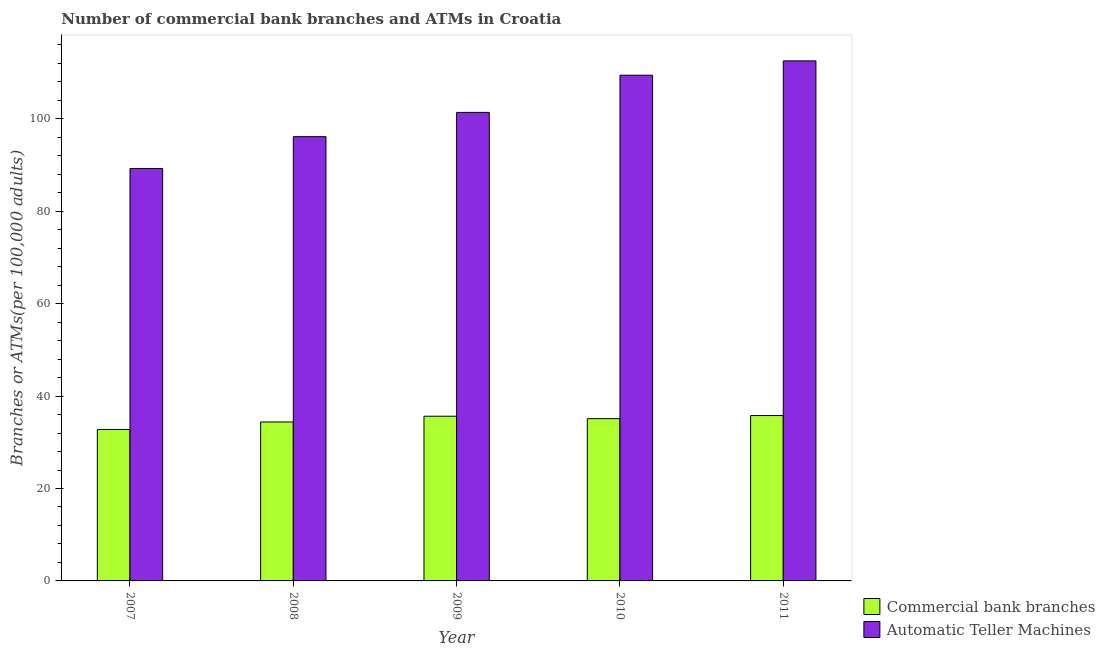How many groups of bars are there?
Provide a succinct answer. 5. Are the number of bars on each tick of the X-axis equal?
Make the answer very short. Yes. How many bars are there on the 5th tick from the right?
Keep it short and to the point. 2. What is the label of the 5th group of bars from the left?
Make the answer very short. 2011. In how many cases, is the number of bars for a given year not equal to the number of legend labels?
Ensure brevity in your answer.  0. What is the number of commercal bank branches in 2008?
Your answer should be very brief. 34.4. Across all years, what is the maximum number of atms?
Ensure brevity in your answer.  112.54. Across all years, what is the minimum number of atms?
Give a very brief answer. 89.25. In which year was the number of atms maximum?
Provide a short and direct response. 2011. In which year was the number of atms minimum?
Offer a terse response. 2007. What is the total number of atms in the graph?
Your answer should be compact. 508.75. What is the difference between the number of commercal bank branches in 2009 and that in 2011?
Keep it short and to the point. -0.15. What is the difference between the number of atms in 2008 and the number of commercal bank branches in 2010?
Give a very brief answer. -13.3. What is the average number of commercal bank branches per year?
Offer a terse response. 34.74. In the year 2007, what is the difference between the number of atms and number of commercal bank branches?
Ensure brevity in your answer.  0. What is the ratio of the number of commercal bank branches in 2008 to that in 2009?
Your answer should be very brief. 0.97. Is the difference between the number of atms in 2007 and 2009 greater than the difference between the number of commercal bank branches in 2007 and 2009?
Your response must be concise. No. What is the difference between the highest and the second highest number of commercal bank branches?
Your response must be concise. 0.15. What is the difference between the highest and the lowest number of atms?
Your answer should be compact. 23.29. In how many years, is the number of commercal bank branches greater than the average number of commercal bank branches taken over all years?
Provide a short and direct response. 3. What does the 1st bar from the left in 2007 represents?
Offer a very short reply. Commercial bank branches. What does the 2nd bar from the right in 2007 represents?
Your answer should be compact. Commercial bank branches. How many bars are there?
Offer a terse response. 10. Are the values on the major ticks of Y-axis written in scientific E-notation?
Offer a very short reply. No. Does the graph contain any zero values?
Ensure brevity in your answer.  No. Where does the legend appear in the graph?
Provide a short and direct response. Bottom right. What is the title of the graph?
Your answer should be compact. Number of commercial bank branches and ATMs in Croatia. Does "Research and Development" appear as one of the legend labels in the graph?
Your answer should be compact. No. What is the label or title of the X-axis?
Ensure brevity in your answer.  Year. What is the label or title of the Y-axis?
Provide a short and direct response. Branches or ATMs(per 100,0 adults). What is the Branches or ATMs(per 100,000 adults) of Commercial bank branches in 2007?
Provide a short and direct response. 32.78. What is the Branches or ATMs(per 100,000 adults) of Automatic Teller Machines in 2007?
Your answer should be very brief. 89.25. What is the Branches or ATMs(per 100,000 adults) of Commercial bank branches in 2008?
Make the answer very short. 34.4. What is the Branches or ATMs(per 100,000 adults) of Automatic Teller Machines in 2008?
Ensure brevity in your answer.  96.14. What is the Branches or ATMs(per 100,000 adults) of Commercial bank branches in 2009?
Ensure brevity in your answer.  35.64. What is the Branches or ATMs(per 100,000 adults) of Automatic Teller Machines in 2009?
Your answer should be very brief. 101.39. What is the Branches or ATMs(per 100,000 adults) of Commercial bank branches in 2010?
Ensure brevity in your answer.  35.12. What is the Branches or ATMs(per 100,000 adults) in Automatic Teller Machines in 2010?
Your answer should be compact. 109.44. What is the Branches or ATMs(per 100,000 adults) in Commercial bank branches in 2011?
Offer a terse response. 35.79. What is the Branches or ATMs(per 100,000 adults) in Automatic Teller Machines in 2011?
Provide a succinct answer. 112.54. Across all years, what is the maximum Branches or ATMs(per 100,000 adults) in Commercial bank branches?
Your answer should be very brief. 35.79. Across all years, what is the maximum Branches or ATMs(per 100,000 adults) of Automatic Teller Machines?
Your answer should be compact. 112.54. Across all years, what is the minimum Branches or ATMs(per 100,000 adults) in Commercial bank branches?
Make the answer very short. 32.78. Across all years, what is the minimum Branches or ATMs(per 100,000 adults) of Automatic Teller Machines?
Ensure brevity in your answer.  89.25. What is the total Branches or ATMs(per 100,000 adults) in Commercial bank branches in the graph?
Your answer should be very brief. 173.72. What is the total Branches or ATMs(per 100,000 adults) of Automatic Teller Machines in the graph?
Your answer should be compact. 508.75. What is the difference between the Branches or ATMs(per 100,000 adults) in Commercial bank branches in 2007 and that in 2008?
Ensure brevity in your answer.  -1.62. What is the difference between the Branches or ATMs(per 100,000 adults) of Automatic Teller Machines in 2007 and that in 2008?
Keep it short and to the point. -6.89. What is the difference between the Branches or ATMs(per 100,000 adults) in Commercial bank branches in 2007 and that in 2009?
Ensure brevity in your answer.  -2.86. What is the difference between the Branches or ATMs(per 100,000 adults) in Automatic Teller Machines in 2007 and that in 2009?
Provide a succinct answer. -12.14. What is the difference between the Branches or ATMs(per 100,000 adults) of Commercial bank branches in 2007 and that in 2010?
Give a very brief answer. -2.34. What is the difference between the Branches or ATMs(per 100,000 adults) in Automatic Teller Machines in 2007 and that in 2010?
Provide a succinct answer. -20.19. What is the difference between the Branches or ATMs(per 100,000 adults) of Commercial bank branches in 2007 and that in 2011?
Ensure brevity in your answer.  -3.01. What is the difference between the Branches or ATMs(per 100,000 adults) in Automatic Teller Machines in 2007 and that in 2011?
Make the answer very short. -23.29. What is the difference between the Branches or ATMs(per 100,000 adults) of Commercial bank branches in 2008 and that in 2009?
Your answer should be compact. -1.25. What is the difference between the Branches or ATMs(per 100,000 adults) of Automatic Teller Machines in 2008 and that in 2009?
Your answer should be compact. -5.25. What is the difference between the Branches or ATMs(per 100,000 adults) of Commercial bank branches in 2008 and that in 2010?
Make the answer very short. -0.72. What is the difference between the Branches or ATMs(per 100,000 adults) in Automatic Teller Machines in 2008 and that in 2010?
Offer a very short reply. -13.3. What is the difference between the Branches or ATMs(per 100,000 adults) of Commercial bank branches in 2008 and that in 2011?
Provide a succinct answer. -1.39. What is the difference between the Branches or ATMs(per 100,000 adults) of Automatic Teller Machines in 2008 and that in 2011?
Provide a short and direct response. -16.4. What is the difference between the Branches or ATMs(per 100,000 adults) in Commercial bank branches in 2009 and that in 2010?
Ensure brevity in your answer.  0.53. What is the difference between the Branches or ATMs(per 100,000 adults) in Automatic Teller Machines in 2009 and that in 2010?
Your answer should be very brief. -8.05. What is the difference between the Branches or ATMs(per 100,000 adults) in Commercial bank branches in 2009 and that in 2011?
Provide a short and direct response. -0.15. What is the difference between the Branches or ATMs(per 100,000 adults) of Automatic Teller Machines in 2009 and that in 2011?
Keep it short and to the point. -11.15. What is the difference between the Branches or ATMs(per 100,000 adults) of Commercial bank branches in 2010 and that in 2011?
Give a very brief answer. -0.68. What is the difference between the Branches or ATMs(per 100,000 adults) of Automatic Teller Machines in 2010 and that in 2011?
Offer a terse response. -3.1. What is the difference between the Branches or ATMs(per 100,000 adults) in Commercial bank branches in 2007 and the Branches or ATMs(per 100,000 adults) in Automatic Teller Machines in 2008?
Make the answer very short. -63.36. What is the difference between the Branches or ATMs(per 100,000 adults) in Commercial bank branches in 2007 and the Branches or ATMs(per 100,000 adults) in Automatic Teller Machines in 2009?
Give a very brief answer. -68.61. What is the difference between the Branches or ATMs(per 100,000 adults) of Commercial bank branches in 2007 and the Branches or ATMs(per 100,000 adults) of Automatic Teller Machines in 2010?
Offer a terse response. -76.66. What is the difference between the Branches or ATMs(per 100,000 adults) of Commercial bank branches in 2007 and the Branches or ATMs(per 100,000 adults) of Automatic Teller Machines in 2011?
Ensure brevity in your answer.  -79.76. What is the difference between the Branches or ATMs(per 100,000 adults) of Commercial bank branches in 2008 and the Branches or ATMs(per 100,000 adults) of Automatic Teller Machines in 2009?
Offer a terse response. -66.99. What is the difference between the Branches or ATMs(per 100,000 adults) of Commercial bank branches in 2008 and the Branches or ATMs(per 100,000 adults) of Automatic Teller Machines in 2010?
Offer a very short reply. -75.04. What is the difference between the Branches or ATMs(per 100,000 adults) in Commercial bank branches in 2008 and the Branches or ATMs(per 100,000 adults) in Automatic Teller Machines in 2011?
Your response must be concise. -78.14. What is the difference between the Branches or ATMs(per 100,000 adults) of Commercial bank branches in 2009 and the Branches or ATMs(per 100,000 adults) of Automatic Teller Machines in 2010?
Provide a succinct answer. -73.79. What is the difference between the Branches or ATMs(per 100,000 adults) in Commercial bank branches in 2009 and the Branches or ATMs(per 100,000 adults) in Automatic Teller Machines in 2011?
Provide a short and direct response. -76.9. What is the difference between the Branches or ATMs(per 100,000 adults) in Commercial bank branches in 2010 and the Branches or ATMs(per 100,000 adults) in Automatic Teller Machines in 2011?
Your answer should be compact. -77.42. What is the average Branches or ATMs(per 100,000 adults) in Commercial bank branches per year?
Your answer should be very brief. 34.74. What is the average Branches or ATMs(per 100,000 adults) in Automatic Teller Machines per year?
Your answer should be very brief. 101.75. In the year 2007, what is the difference between the Branches or ATMs(per 100,000 adults) in Commercial bank branches and Branches or ATMs(per 100,000 adults) in Automatic Teller Machines?
Give a very brief answer. -56.47. In the year 2008, what is the difference between the Branches or ATMs(per 100,000 adults) in Commercial bank branches and Branches or ATMs(per 100,000 adults) in Automatic Teller Machines?
Provide a short and direct response. -61.74. In the year 2009, what is the difference between the Branches or ATMs(per 100,000 adults) in Commercial bank branches and Branches or ATMs(per 100,000 adults) in Automatic Teller Machines?
Offer a terse response. -65.75. In the year 2010, what is the difference between the Branches or ATMs(per 100,000 adults) of Commercial bank branches and Branches or ATMs(per 100,000 adults) of Automatic Teller Machines?
Your response must be concise. -74.32. In the year 2011, what is the difference between the Branches or ATMs(per 100,000 adults) of Commercial bank branches and Branches or ATMs(per 100,000 adults) of Automatic Teller Machines?
Give a very brief answer. -76.75. What is the ratio of the Branches or ATMs(per 100,000 adults) of Commercial bank branches in 2007 to that in 2008?
Ensure brevity in your answer.  0.95. What is the ratio of the Branches or ATMs(per 100,000 adults) in Automatic Teller Machines in 2007 to that in 2008?
Your answer should be very brief. 0.93. What is the ratio of the Branches or ATMs(per 100,000 adults) in Commercial bank branches in 2007 to that in 2009?
Offer a very short reply. 0.92. What is the ratio of the Branches or ATMs(per 100,000 adults) of Automatic Teller Machines in 2007 to that in 2009?
Provide a short and direct response. 0.88. What is the ratio of the Branches or ATMs(per 100,000 adults) of Commercial bank branches in 2007 to that in 2010?
Make the answer very short. 0.93. What is the ratio of the Branches or ATMs(per 100,000 adults) of Automatic Teller Machines in 2007 to that in 2010?
Provide a succinct answer. 0.82. What is the ratio of the Branches or ATMs(per 100,000 adults) in Commercial bank branches in 2007 to that in 2011?
Provide a short and direct response. 0.92. What is the ratio of the Branches or ATMs(per 100,000 adults) of Automatic Teller Machines in 2007 to that in 2011?
Your answer should be compact. 0.79. What is the ratio of the Branches or ATMs(per 100,000 adults) of Automatic Teller Machines in 2008 to that in 2009?
Provide a short and direct response. 0.95. What is the ratio of the Branches or ATMs(per 100,000 adults) of Commercial bank branches in 2008 to that in 2010?
Provide a short and direct response. 0.98. What is the ratio of the Branches or ATMs(per 100,000 adults) in Automatic Teller Machines in 2008 to that in 2010?
Ensure brevity in your answer.  0.88. What is the ratio of the Branches or ATMs(per 100,000 adults) in Automatic Teller Machines in 2008 to that in 2011?
Keep it short and to the point. 0.85. What is the ratio of the Branches or ATMs(per 100,000 adults) in Automatic Teller Machines in 2009 to that in 2010?
Make the answer very short. 0.93. What is the ratio of the Branches or ATMs(per 100,000 adults) in Commercial bank branches in 2009 to that in 2011?
Make the answer very short. 1. What is the ratio of the Branches or ATMs(per 100,000 adults) in Automatic Teller Machines in 2009 to that in 2011?
Keep it short and to the point. 0.9. What is the ratio of the Branches or ATMs(per 100,000 adults) in Commercial bank branches in 2010 to that in 2011?
Provide a succinct answer. 0.98. What is the ratio of the Branches or ATMs(per 100,000 adults) of Automatic Teller Machines in 2010 to that in 2011?
Provide a succinct answer. 0.97. What is the difference between the highest and the second highest Branches or ATMs(per 100,000 adults) in Commercial bank branches?
Offer a terse response. 0.15. What is the difference between the highest and the second highest Branches or ATMs(per 100,000 adults) in Automatic Teller Machines?
Your answer should be compact. 3.1. What is the difference between the highest and the lowest Branches or ATMs(per 100,000 adults) of Commercial bank branches?
Offer a very short reply. 3.01. What is the difference between the highest and the lowest Branches or ATMs(per 100,000 adults) in Automatic Teller Machines?
Offer a terse response. 23.29. 